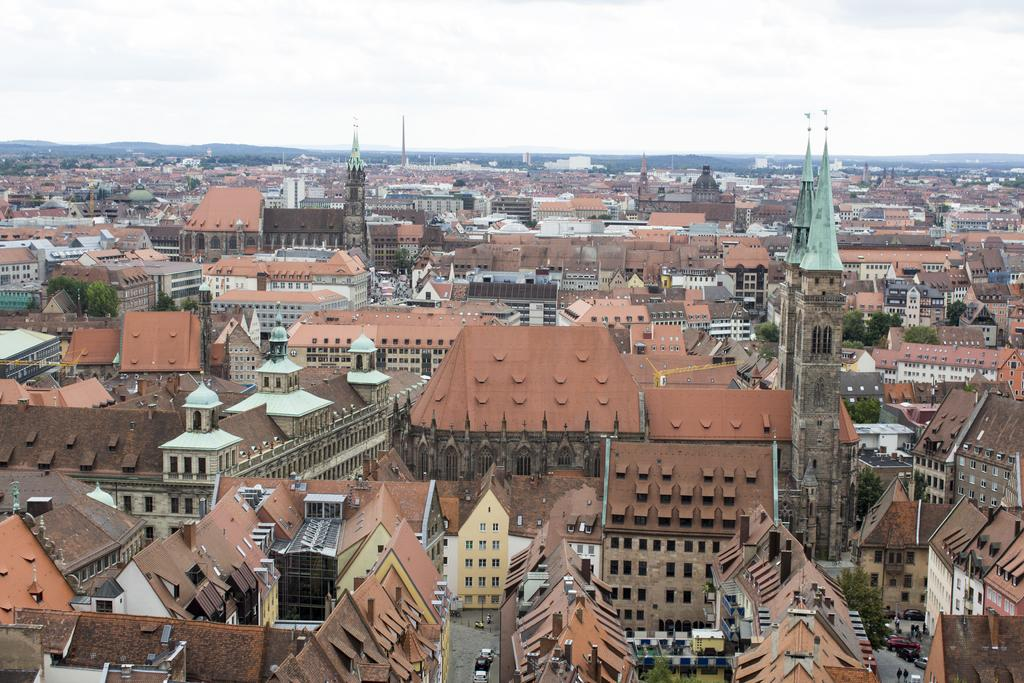What type of structures can be seen in the image? There are buildings in the image. What other natural elements are present in the image? There are trees in the image. What man-made objects can be seen in the image? There are vehicles in the image. Are there any people visible in the image? Yes, there are persons in the image. What can be seen in the background of the image? The sky is visible in the background of the image. Can you tell me how many snakes are wrapped around the trees in the image? There are no snakes present in the image; it features buildings, trees, vehicles, persons, and a visible sky. What type of lace is used to decorate the buildings in the image? There is no lace present in the image; the buildings are not decorated with lace. 